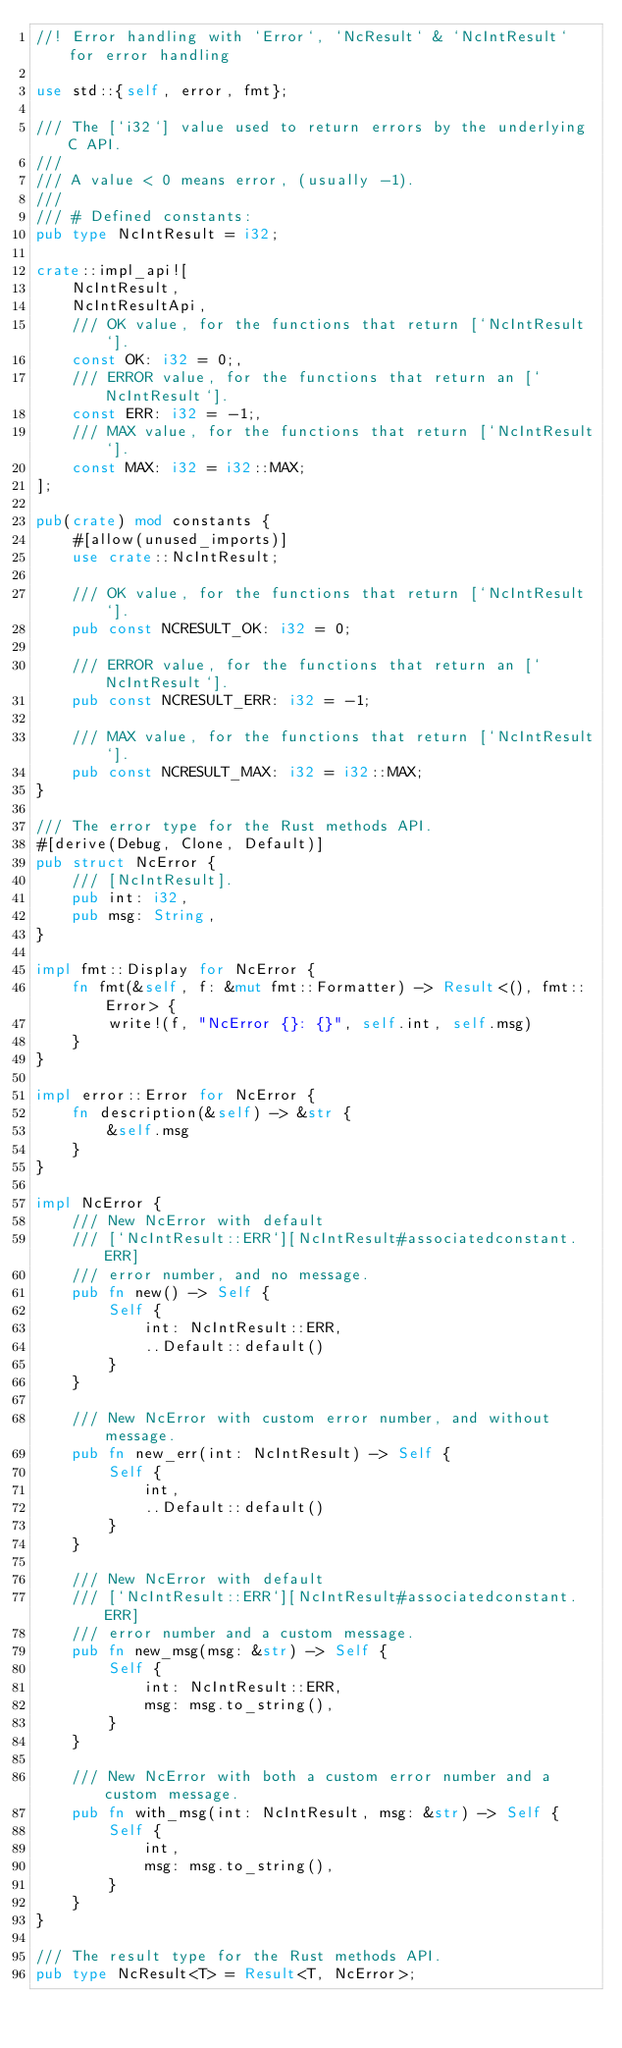Convert code to text. <code><loc_0><loc_0><loc_500><loc_500><_Rust_>//! Error handling with `Error`, `NcResult` & `NcIntResult` for error handling

use std::{self, error, fmt};

/// The [`i32`] value used to return errors by the underlying C API.
///
/// A value < 0 means error, (usually -1).
///
/// # Defined constants:
pub type NcIntResult = i32;

crate::impl_api![
    NcIntResult,
    NcIntResultApi,
    /// OK value, for the functions that return [`NcIntResult`].
    const OK: i32 = 0;,
    /// ERROR value, for the functions that return an [`NcIntResult`].
    const ERR: i32 = -1;,
    /// MAX value, for the functions that return [`NcIntResult`].
    const MAX: i32 = i32::MAX;
];

pub(crate) mod constants {
    #[allow(unused_imports)]
    use crate::NcIntResult;

    /// OK value, for the functions that return [`NcIntResult`].
    pub const NCRESULT_OK: i32 = 0;

    /// ERROR value, for the functions that return an [`NcIntResult`].
    pub const NCRESULT_ERR: i32 = -1;

    /// MAX value, for the functions that return [`NcIntResult`].
    pub const NCRESULT_MAX: i32 = i32::MAX;
}

/// The error type for the Rust methods API.
#[derive(Debug, Clone, Default)]
pub struct NcError {
    /// [NcIntResult].
    pub int: i32,
    pub msg: String,
}

impl fmt::Display for NcError {
    fn fmt(&self, f: &mut fmt::Formatter) -> Result<(), fmt::Error> {
        write!(f, "NcError {}: {}", self.int, self.msg)
    }
}

impl error::Error for NcError {
    fn description(&self) -> &str {
        &self.msg
    }
}

impl NcError {
    /// New NcError with default
    /// [`NcIntResult::ERR`][NcIntResult#associatedconstant.ERR]
    /// error number, and no message.
    pub fn new() -> Self {
        Self {
            int: NcIntResult::ERR,
            ..Default::default()
        }
    }

    /// New NcError with custom error number, and without message.
    pub fn new_err(int: NcIntResult) -> Self {
        Self {
            int,
            ..Default::default()
        }
    }

    /// New NcError with default
    /// [`NcIntResult::ERR`][NcIntResult#associatedconstant.ERR]
    /// error number and a custom message.
    pub fn new_msg(msg: &str) -> Self {
        Self {
            int: NcIntResult::ERR,
            msg: msg.to_string(),
        }
    }

    /// New NcError with both a custom error number and a custom message.
    pub fn with_msg(int: NcIntResult, msg: &str) -> Self {
        Self {
            int,
            msg: msg.to_string(),
        }
    }
}

/// The result type for the Rust methods API.
pub type NcResult<T> = Result<T, NcError>;
</code> 